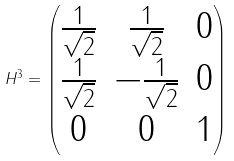<formula> <loc_0><loc_0><loc_500><loc_500>H ^ { 3 } = \begin{pmatrix} \frac { 1 } { \sqrt { 2 } } & \frac { 1 } { \sqrt { 2 } } & 0 \\ \frac { 1 } { \sqrt { 2 } } & - \frac { 1 } { \sqrt { 2 } } & 0 \\ 0 & 0 & 1 \end{pmatrix}</formula> 